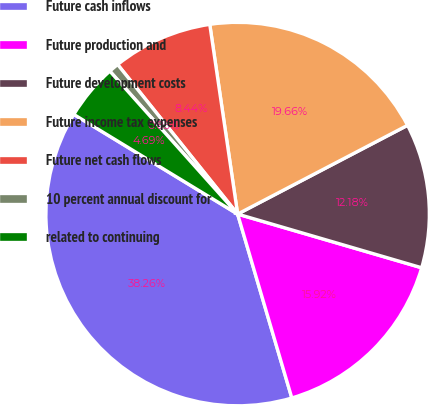Convert chart to OTSL. <chart><loc_0><loc_0><loc_500><loc_500><pie_chart><fcel>Future cash inflows<fcel>Future production and<fcel>Future development costs<fcel>Future income tax expenses<fcel>Future net cash flows<fcel>10 percent annual discount for<fcel>related to continuing<nl><fcel>38.26%<fcel>15.92%<fcel>12.18%<fcel>19.66%<fcel>8.44%<fcel>0.85%<fcel>4.69%<nl></chart> 